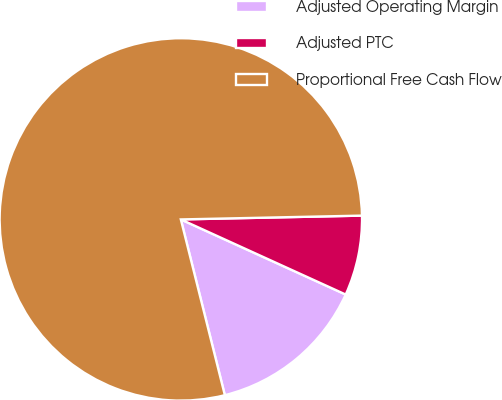<chart> <loc_0><loc_0><loc_500><loc_500><pie_chart><fcel>Adjusted Operating Margin<fcel>Adjusted PTC<fcel>Proportional Free Cash Flow<nl><fcel>14.29%<fcel>7.14%<fcel>78.57%<nl></chart> 